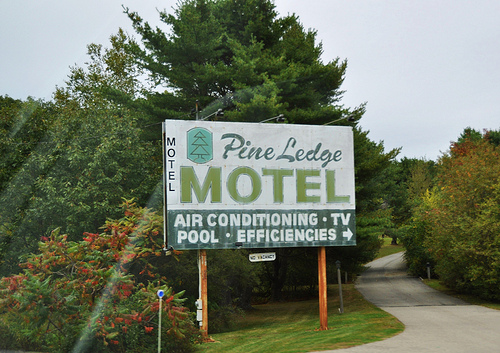<image>
Can you confirm if the tree is behind the sign? Yes. From this viewpoint, the tree is positioned behind the sign, with the sign partially or fully occluding the tree. 